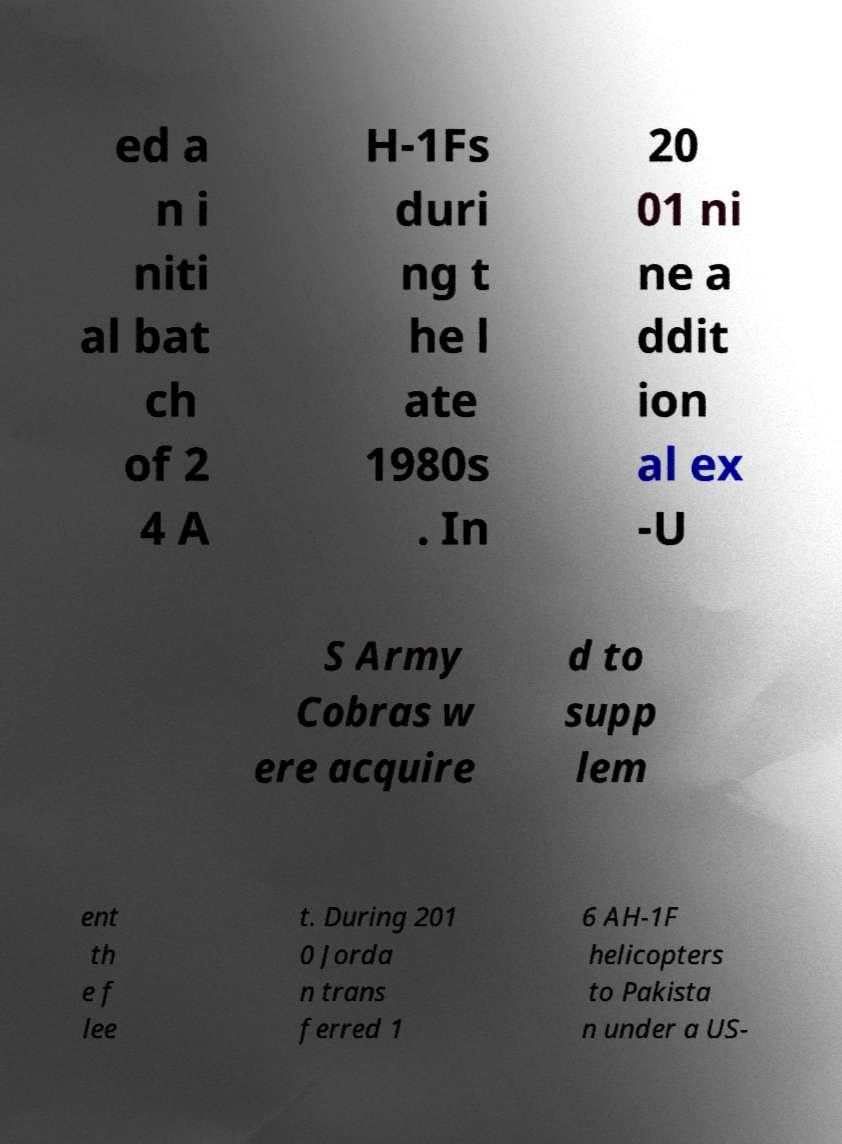Can you read and provide the text displayed in the image?This photo seems to have some interesting text. Can you extract and type it out for me? ed a n i niti al bat ch of 2 4 A H-1Fs duri ng t he l ate 1980s . In 20 01 ni ne a ddit ion al ex -U S Army Cobras w ere acquire d to supp lem ent th e f lee t. During 201 0 Jorda n trans ferred 1 6 AH-1F helicopters to Pakista n under a US- 